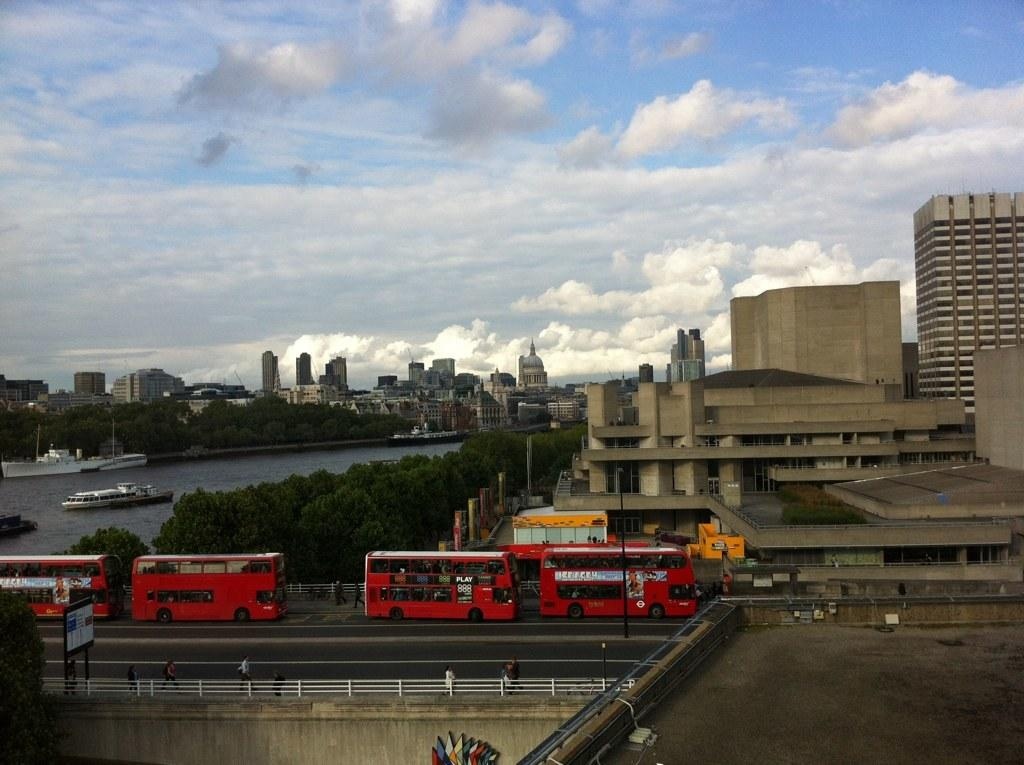What type of buses are in the image? There are double decker buses in the image. What color are the buses? The buses are red in color. Where are the buses located? The buses are on the road. What can be seen in the background of the image? There are buildings, trees, and ships on the water in the background of the image. What type of bell can be heard ringing in the image? There is no bell present or ringing in the image. Is there a light illuminating the buses in the image? The image does not provide information about any lights illuminating the buses. 